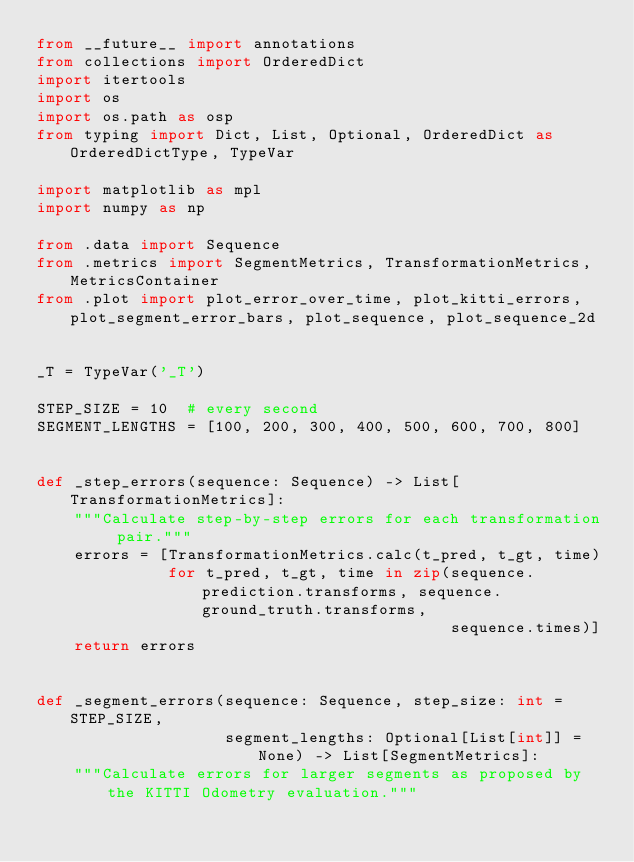<code> <loc_0><loc_0><loc_500><loc_500><_Python_>from __future__ import annotations
from collections import OrderedDict
import itertools
import os
import os.path as osp
from typing import Dict, List, Optional, OrderedDict as OrderedDictType, TypeVar

import matplotlib as mpl
import numpy as np

from .data import Sequence
from .metrics import SegmentMetrics, TransformationMetrics, MetricsContainer
from .plot import plot_error_over_time, plot_kitti_errors, plot_segment_error_bars, plot_sequence, plot_sequence_2d


_T = TypeVar('_T')

STEP_SIZE = 10  # every second
SEGMENT_LENGTHS = [100, 200, 300, 400, 500, 600, 700, 800]


def _step_errors(sequence: Sequence) -> List[TransformationMetrics]:
    """Calculate step-by-step errors for each transformation pair."""
    errors = [TransformationMetrics.calc(t_pred, t_gt, time)
              for t_pred, t_gt, time in zip(sequence.prediction.transforms, sequence.ground_truth.transforms,
                                            sequence.times)]
    return errors


def _segment_errors(sequence: Sequence, step_size: int = STEP_SIZE,
                    segment_lengths: Optional[List[int]] = None) -> List[SegmentMetrics]:
    """Calculate errors for larger segments as proposed by the KITTI Odometry evaluation."""</code> 